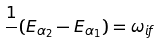<formula> <loc_0><loc_0><loc_500><loc_500>\frac { 1 } { } ( E _ { \alpha _ { 2 } } - E _ { \alpha _ { 1 } } ) = \omega _ { i f }</formula> 